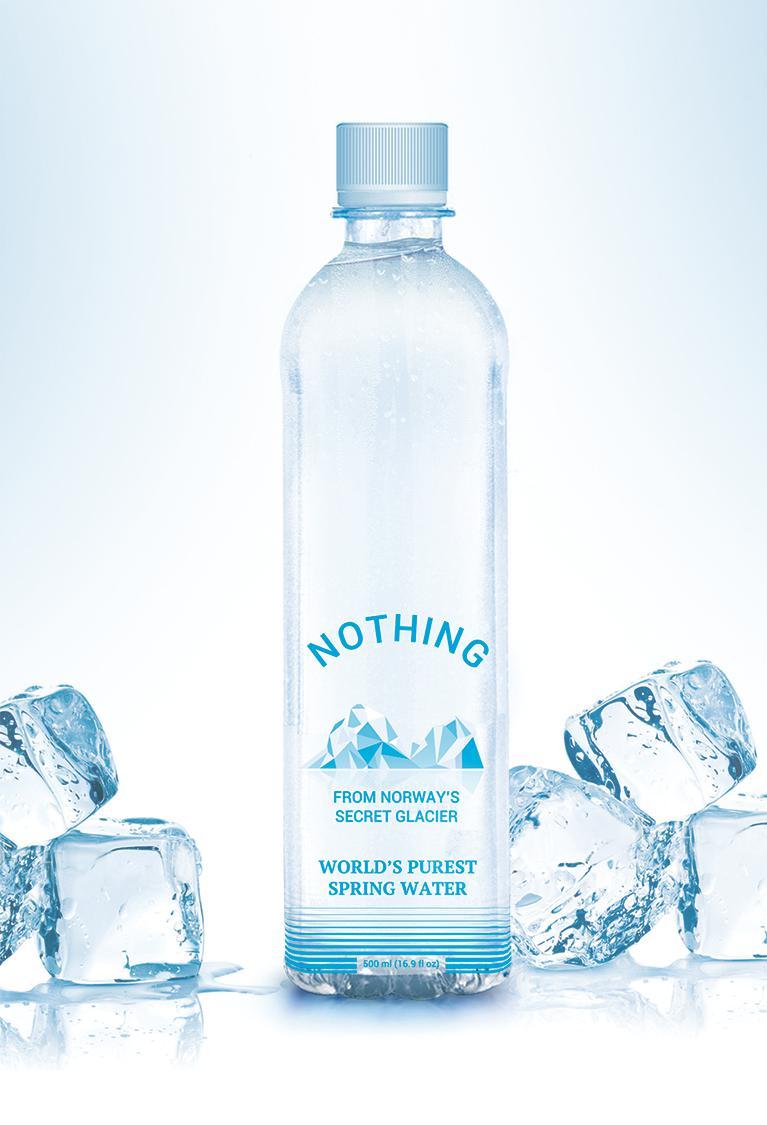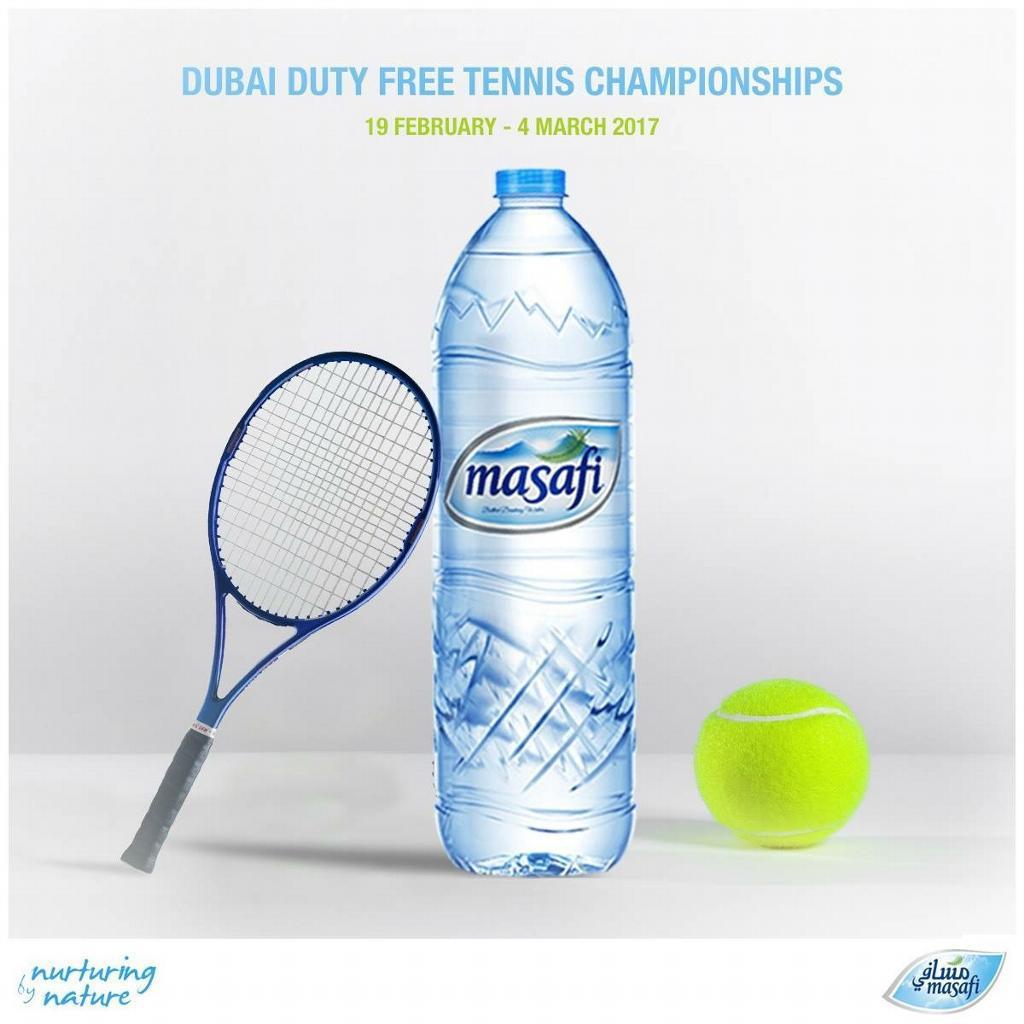The first image is the image on the left, the second image is the image on the right. For the images displayed, is the sentence "There is at least one tennis ball near a water bottle." factually correct? Answer yes or no. Yes. The first image is the image on the left, the second image is the image on the right. Examine the images to the left and right. Is the description "At least one image includes a yellow tennis ball next to a water bottle." accurate? Answer yes or no. Yes. 